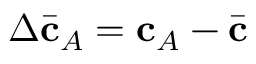<formula> <loc_0><loc_0><loc_500><loc_500>\Delta \bar { c } _ { A } = c _ { A } - \bar { c }</formula> 